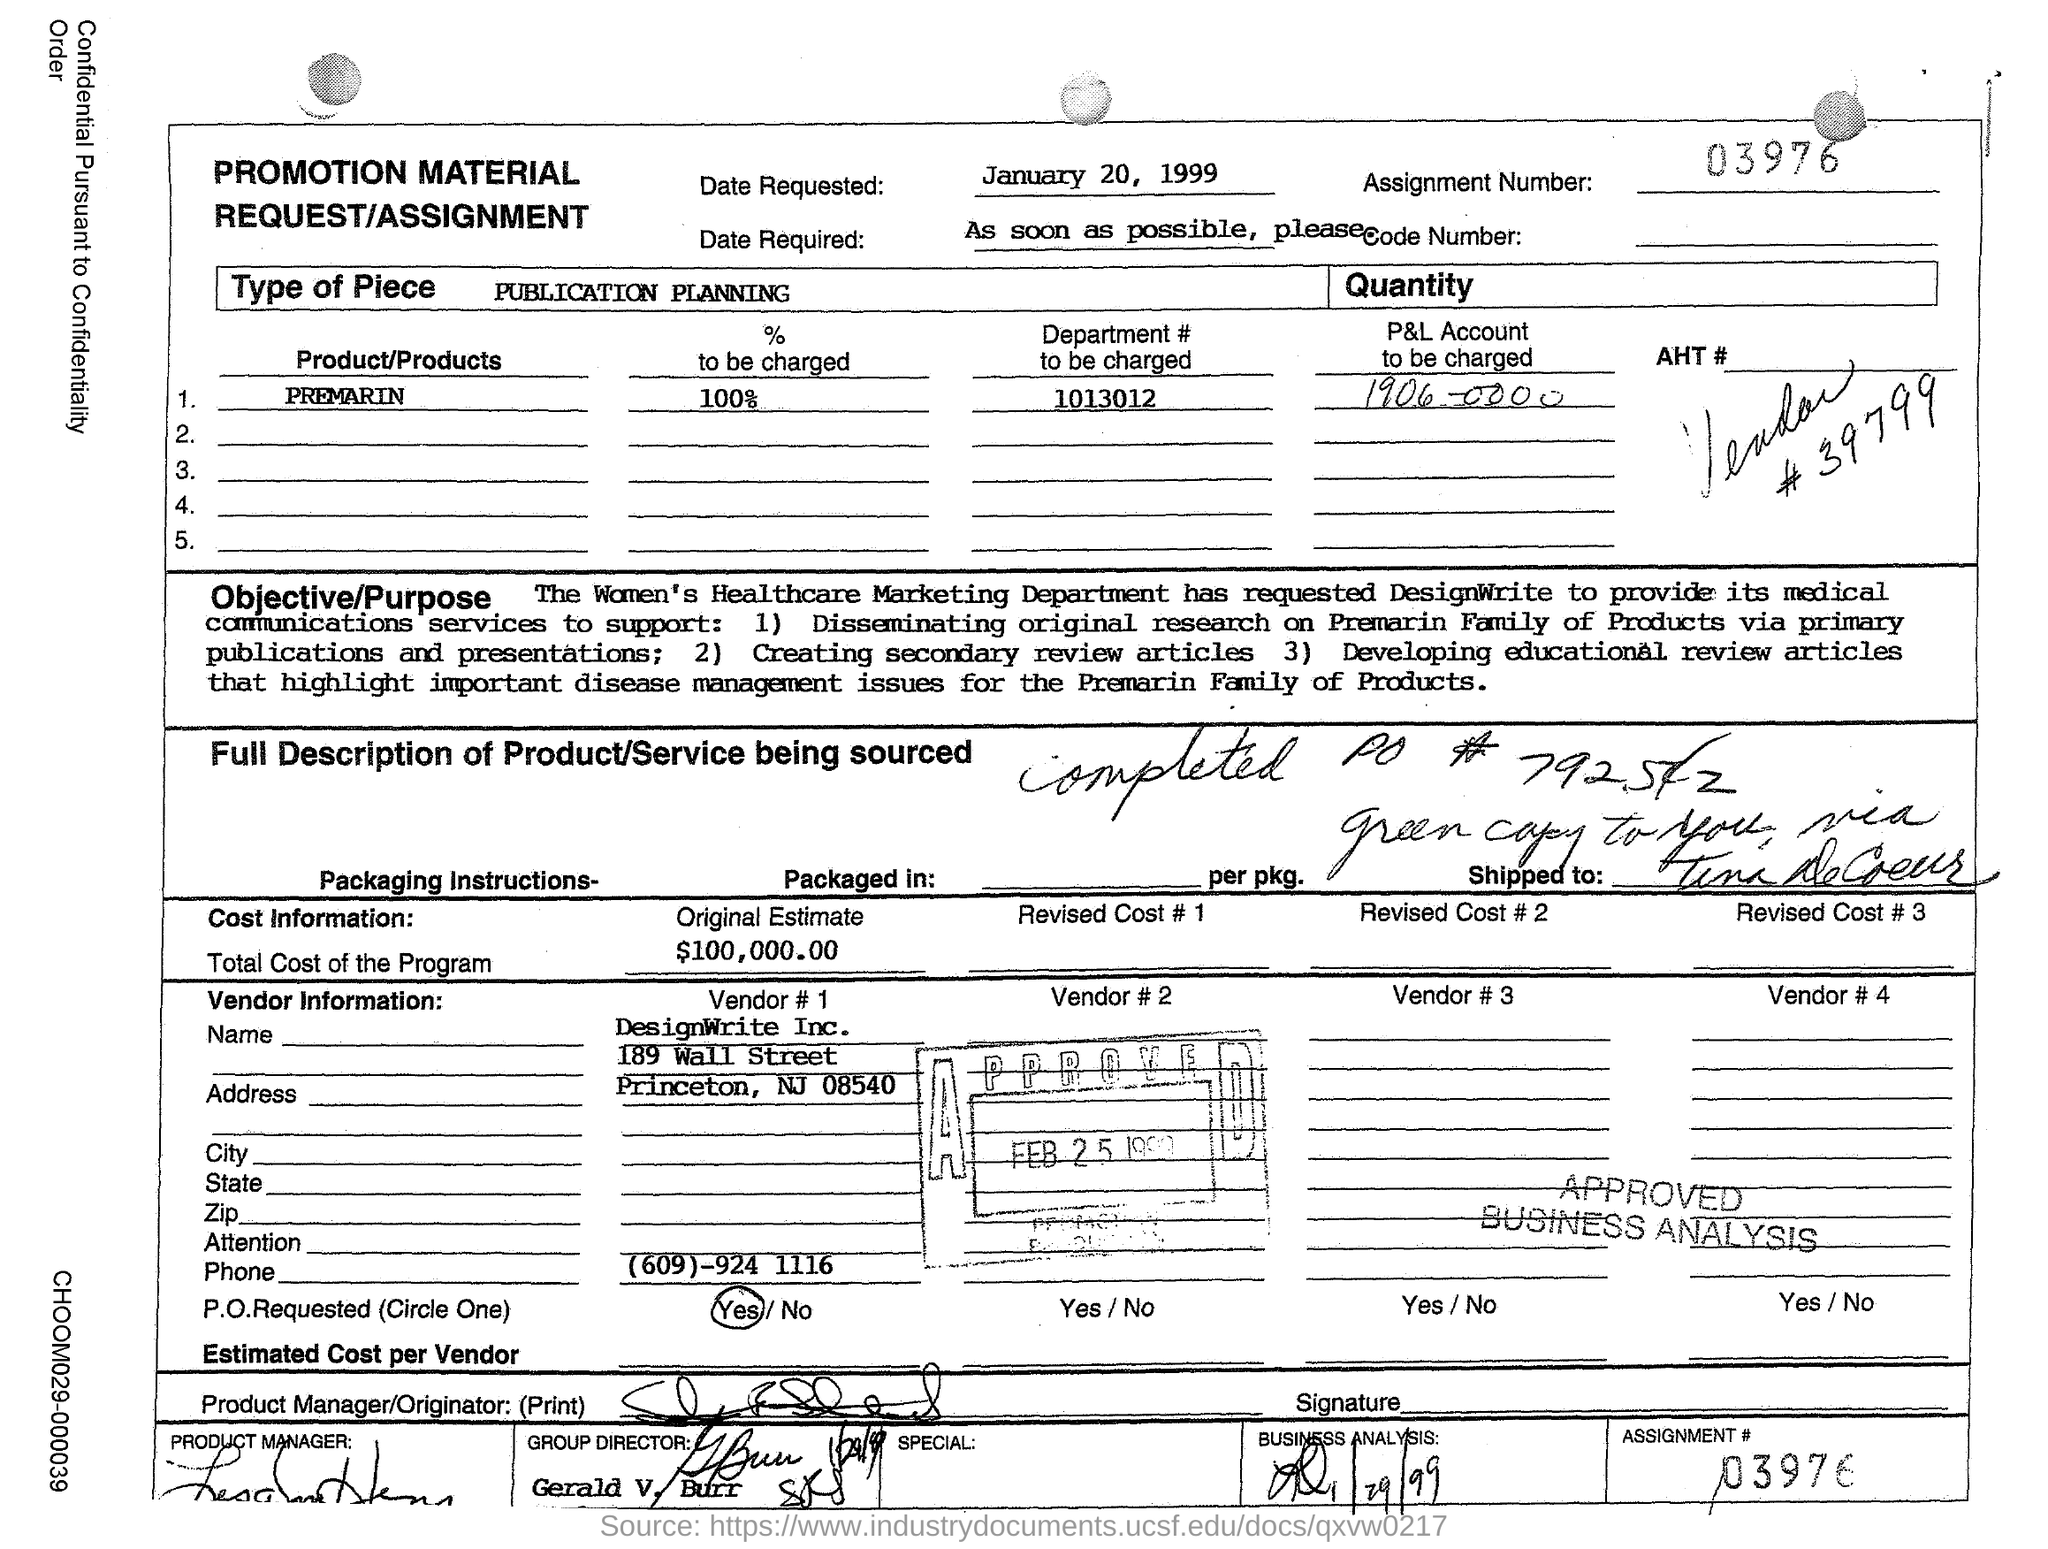Specify some key components in this picture. Premarin is the product or products. The date requested is January 20, 1999. Please provide the appropriate department to be charged for this request. DesignWrite Inc. is the Vendor #1. I have been asked to determine the percentage of a charge that will be applied. 